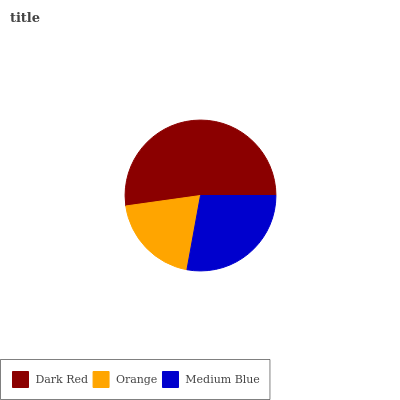Is Orange the minimum?
Answer yes or no. Yes. Is Dark Red the maximum?
Answer yes or no. Yes. Is Medium Blue the minimum?
Answer yes or no. No. Is Medium Blue the maximum?
Answer yes or no. No. Is Medium Blue greater than Orange?
Answer yes or no. Yes. Is Orange less than Medium Blue?
Answer yes or no. Yes. Is Orange greater than Medium Blue?
Answer yes or no. No. Is Medium Blue less than Orange?
Answer yes or no. No. Is Medium Blue the high median?
Answer yes or no. Yes. Is Medium Blue the low median?
Answer yes or no. Yes. Is Dark Red the high median?
Answer yes or no. No. Is Dark Red the low median?
Answer yes or no. No. 